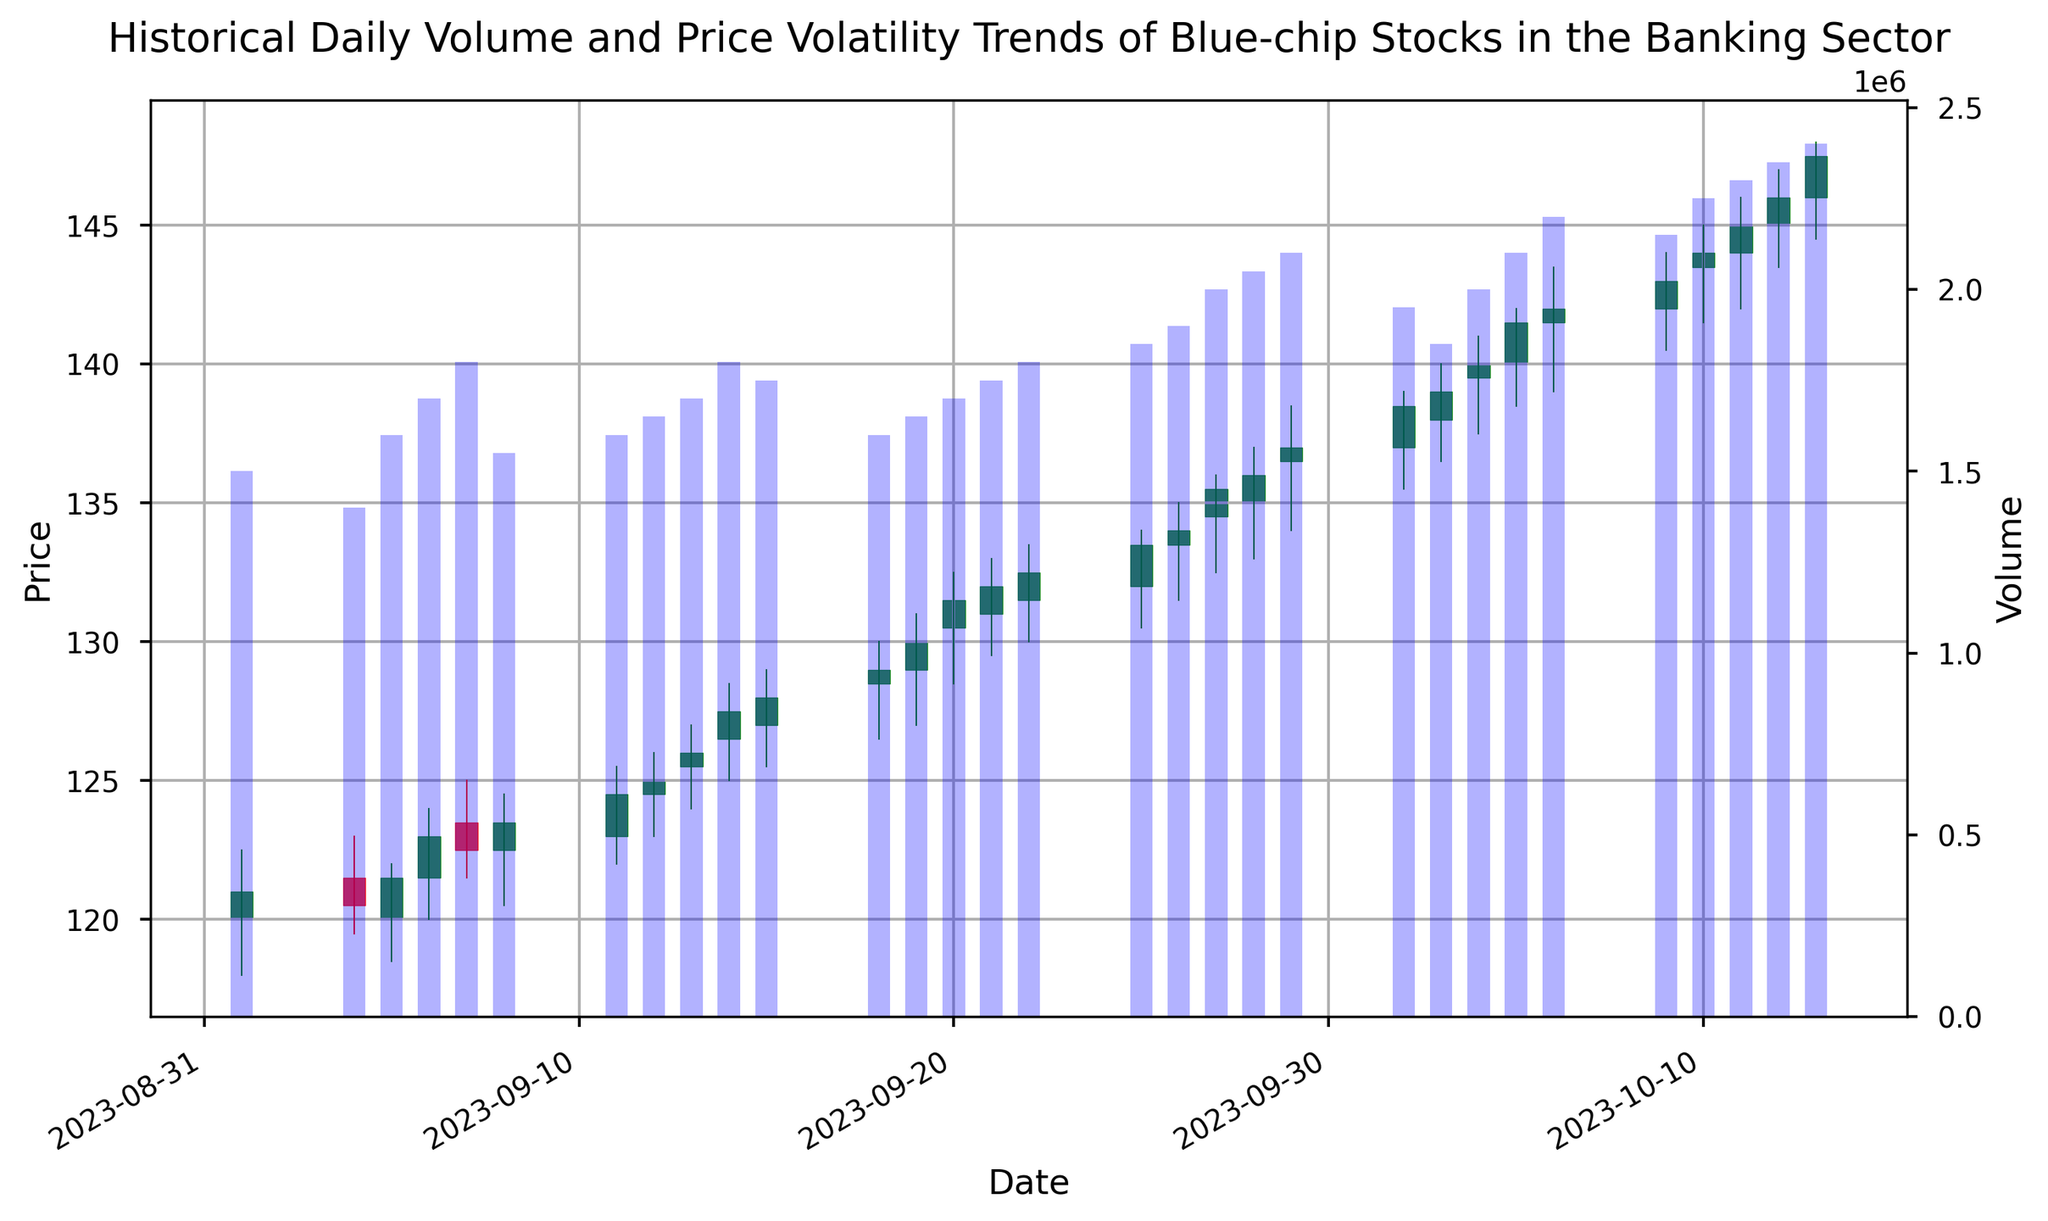What is the general trend of the stock prices throughout the given period? By looking at the candlestick chart, we can observe that the stock prices generally move upward from the beginning to the end of the given period. The opening price on 2023-09-01 was around 120, and the closing price on 2023-10-13 was around 147.50. This indicates a general upward trend.
Answer: Upward Which date has the highest trading volume? By examining the volume bar plot at the bottom of the figure, the highest bar represents the date with the highest trading volume. The highest trading volume corresponds to the date 2023-10-13, with a volume of 2,400,000.
Answer: 2023-10-13 Compare the highest closing price within September to the highest closing price within October. What can you infer? The highest closing price in September is on 2023-09-29 with a closing price of 137.00. The highest closing price in October is on 2023-10-13 with a closing price of 147.50. Comparing these, the highest closing price in October is higher than that in September.
Answer: The highest closing price in October is higher What is the average trading volume over the entire period shown? To find the average trading volume, sum up all the daily volumes and then divide by the number of days. Sum of volumes = 44,350,000, Number of days = 31. Average volume = 44,350,000 / 31.
Answer: Approx. 1,430,645 How does the closing price on 2023-09-01 compare to the closing price on 2023-10-13? The closing price on 2023-09-01 is 121.00, and the closing price on 2023-10-13 is 147.50. Comparing these, the closing price on 2023-10-13 is higher.
Answer: 2023-10-13 is higher Identify the largest single-day price increase. Which date did it occur on and what was the increase? The largest single-day price increase is determined by subtracting the lowest price from the highest price within that day. The largest increase occurred on 2023-10-05, with the highest price at 142.00 and the lowest at 138.50. The increase is 142.00 - 138.50 = 3.50.
Answer: 2023-10-05, 3.50 What pattern do you observe in the volume bars associated with increasing stock prices? The volume bars generally show an upward trend along with the upward trend in stock prices, indicating an increase in trading activity as the stock prices increase.
Answer: Increasing trend Calculate the median closing price for September. To find the median closing price, list all closing prices in September and find the middle value. Sorting and picking middle: 120.50, 121.00, 121.50, 122.50, 123.00, 123.50, 124.50, 125.00, 126.00, 127.50, 128.00, 129.00, 130.00, 131.50, 132.00. Median = 126.00.
Answer: 126.00 Compare the average closing price of the first week (2023-09-01 to 2023-09-08) with the last week (2023-10-09 to 2023-10-13) shown in the chart. Calculate the average for each week: First week closing prices: 121.00, 120.50, 121.50, 123.00, 122.50, 123.50, 124.50. Average = 122.07. Last week closing prices: 143.00, 144.00, 145.00, 146.00, 147.50. Average = 145.10.
Answer: Last week is higher How does the volume traded on 2023-10-05 compare to 2023-10-09? From the volume bars, we see that the volume on 2023-10-05 is 2,100,000, and on 2023-10-09 it is 2,150,000. The volume on 2023-10-09 is higher.
Answer: 2023-10-09 is higher 